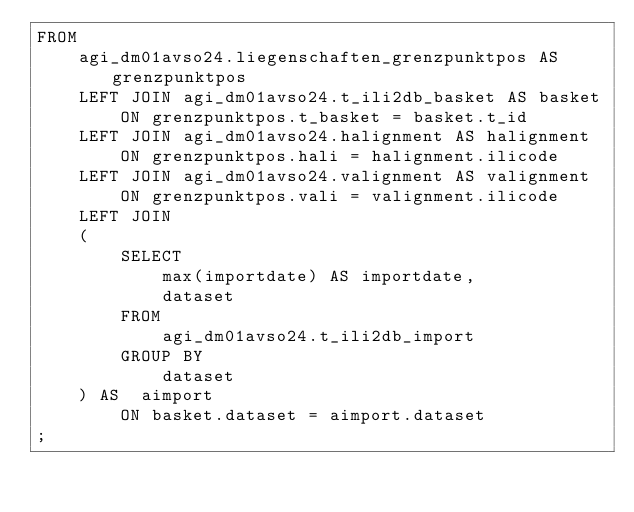<code> <loc_0><loc_0><loc_500><loc_500><_SQL_>FROM
    agi_dm01avso24.liegenschaften_grenzpunktpos AS grenzpunktpos
    LEFT JOIN agi_dm01avso24.t_ili2db_basket AS basket
        ON grenzpunktpos.t_basket = basket.t_id
    LEFT JOIN agi_dm01avso24.halignment AS halignment
        ON grenzpunktpos.hali = halignment.ilicode
    LEFT JOIN agi_dm01avso24.valignment AS valignment
        ON grenzpunktpos.vali = valignment.ilicode
    LEFT JOIN 
    (
        SELECT
            max(importdate) AS importdate,
            dataset
        FROM
            agi_dm01avso24.t_ili2db_import
        GROUP BY
            dataset 
    ) AS  aimport
        ON basket.dataset = aimport.dataset
;
</code> 